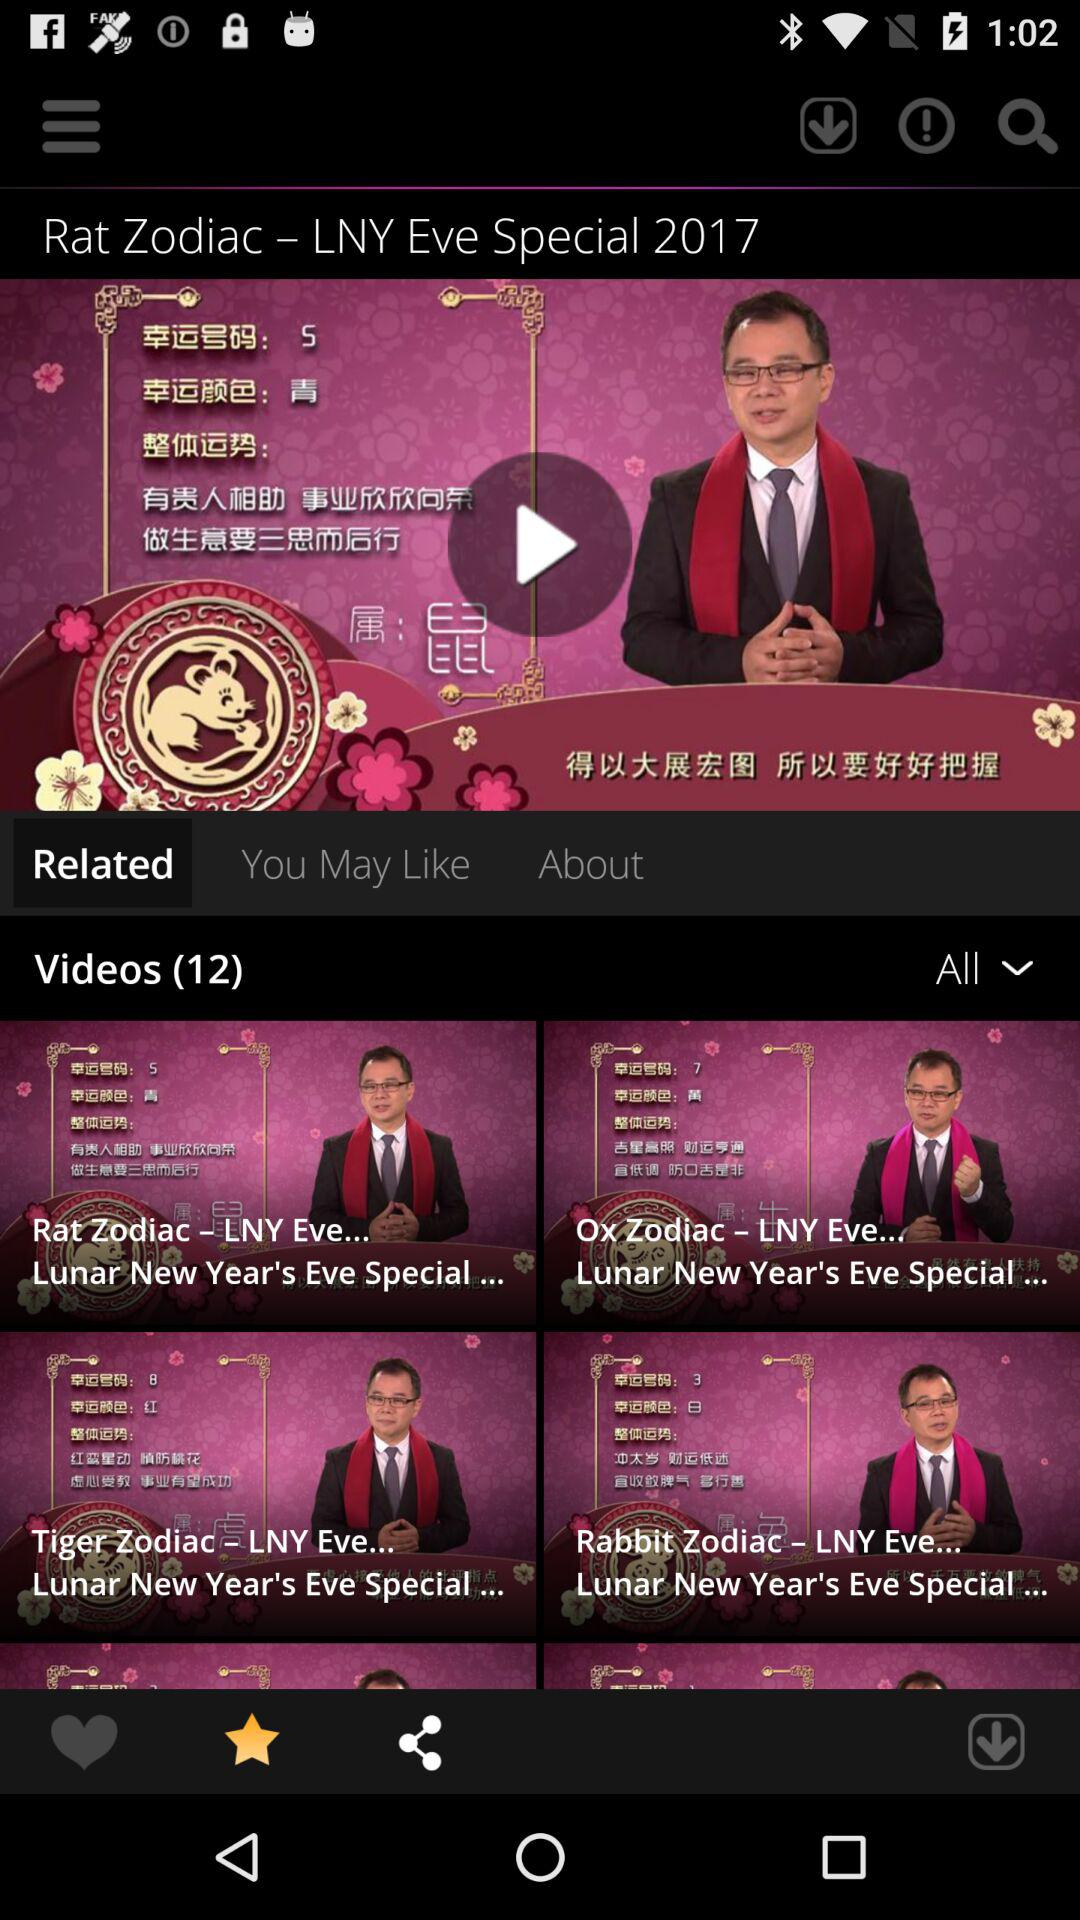How many videos are there in total?
Answer the question using a single word or phrase. 12 